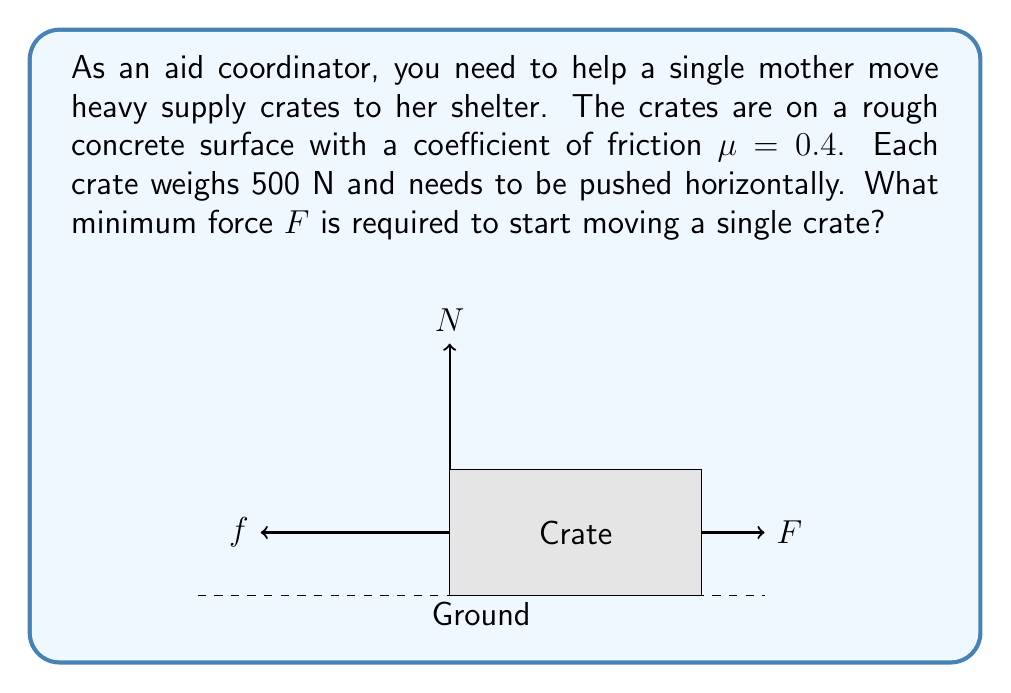Give your solution to this math problem. To determine the minimum force required to start moving the crate, we need to consider the forces acting on it:

1) The weight of the crate ($W = 500$ N) is balanced by the normal force ($N$) from the ground.

2) The friction force ($f$) opposes the motion and is given by:
   $f = \mu N$, where $\mu$ is the coefficient of friction.

3) For the crate to start moving, the applied force $F$ must be equal to the friction force $f$.

4) We know that $N = W = 500$ N (since there's no vertical acceleration).

5) Calculate the friction force:
   $f = \mu N = 0.4 \times 500 = 200$ N

6) Therefore, the minimum force $F$ required to start moving the crate is:
   $F = f = 200$ N

This force needs to be applied horizontally to overcome the static friction and initiate motion.
Answer: $F = 200$ N 